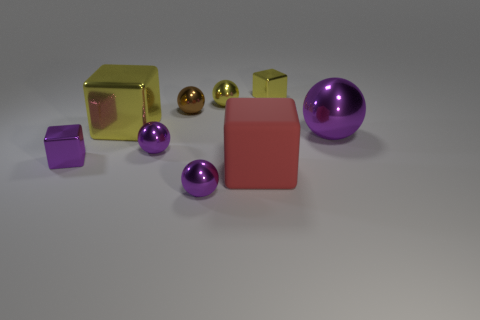Subtract all purple balls. How many were subtracted if there are1purple balls left? 2 Subtract all brown blocks. How many purple balls are left? 3 Subtract all brown spheres. How many spheres are left? 4 Subtract all big metal spheres. How many spheres are left? 4 Subtract all gray cubes. Subtract all purple cylinders. How many cubes are left? 4 Subtract all blocks. How many objects are left? 5 Add 6 red cubes. How many red cubes exist? 7 Subtract 1 yellow balls. How many objects are left? 8 Subtract all small blocks. Subtract all yellow cubes. How many objects are left? 5 Add 9 yellow spheres. How many yellow spheres are left? 10 